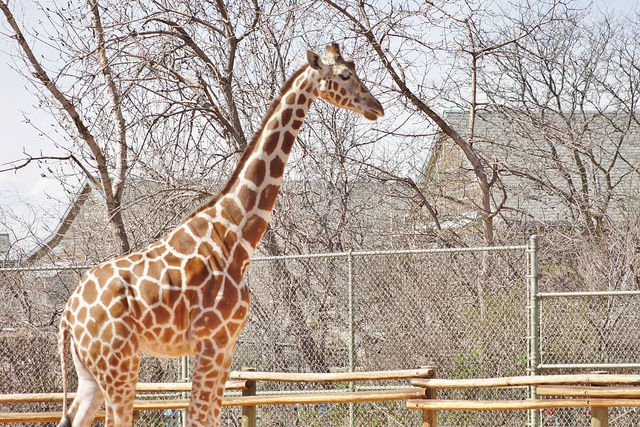Describe the objects in this image and their specific colors. I can see a giraffe in gray, brown, ivory, and tan tones in this image. 